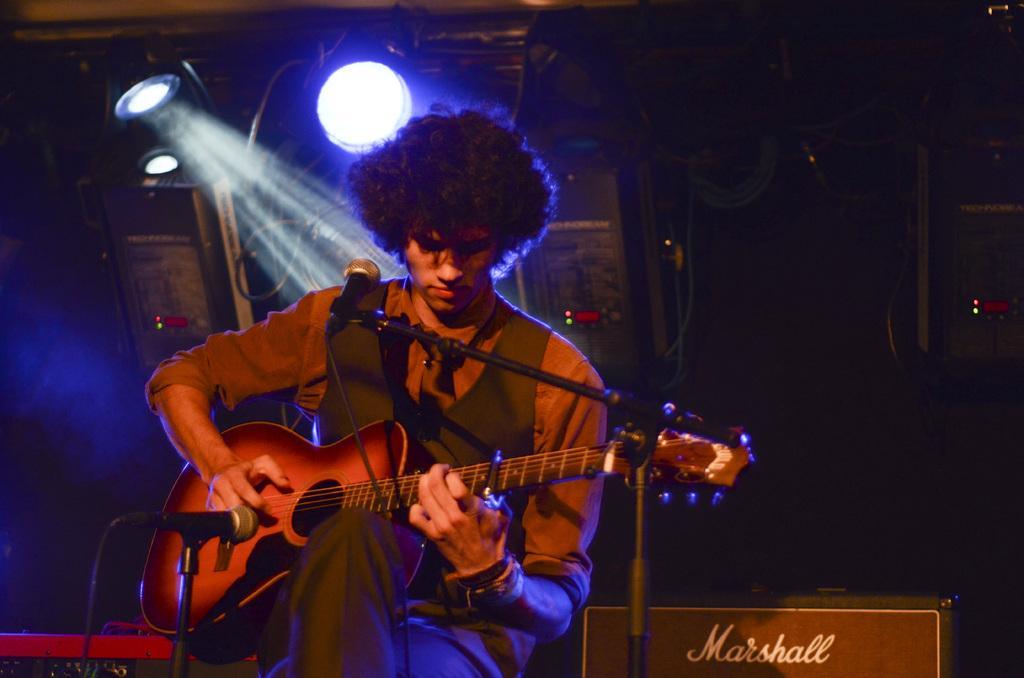How would you summarize this image in a sentence or two? In this picture there is a man sitting, holding and playing a guitar. In front of him there are two microphones and stands. Beside him there is a box on which text "Marshall" is written on it. In the background there are cables, spotlights and boxes. 